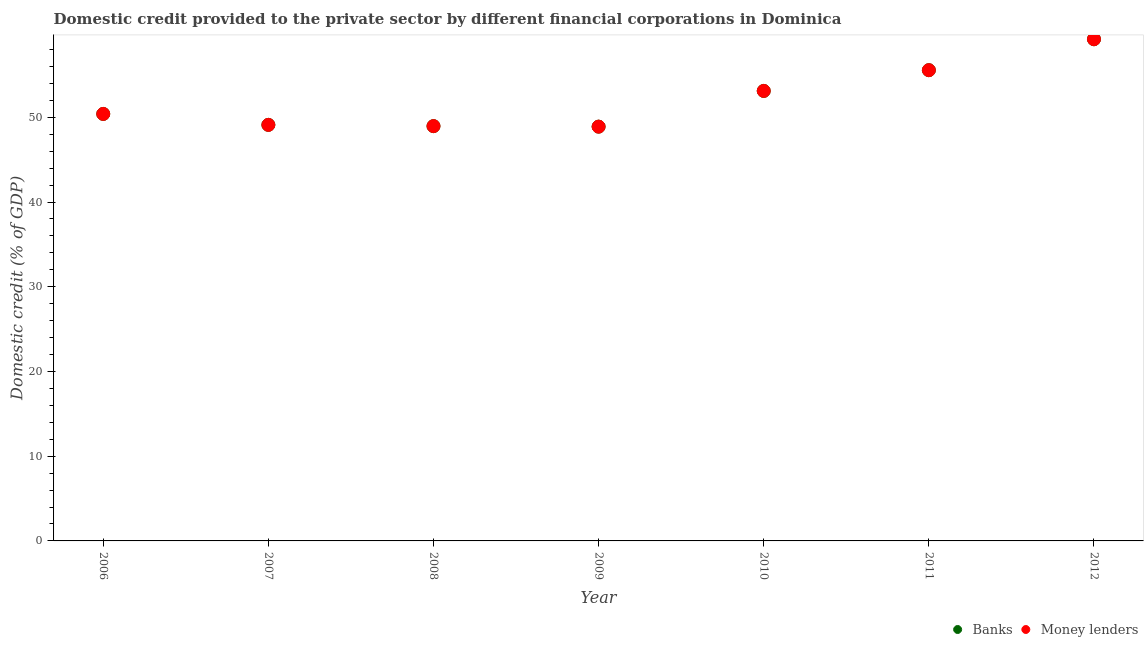How many different coloured dotlines are there?
Keep it short and to the point. 2. What is the domestic credit provided by money lenders in 2011?
Your answer should be compact. 55.56. Across all years, what is the maximum domestic credit provided by banks?
Your response must be concise. 59.21. Across all years, what is the minimum domestic credit provided by money lenders?
Offer a terse response. 48.9. In which year was the domestic credit provided by banks maximum?
Keep it short and to the point. 2012. What is the total domestic credit provided by banks in the graph?
Give a very brief answer. 365.26. What is the difference between the domestic credit provided by banks in 2006 and that in 2010?
Ensure brevity in your answer.  -2.72. What is the difference between the domestic credit provided by banks in 2010 and the domestic credit provided by money lenders in 2009?
Provide a succinct answer. 4.22. What is the average domestic credit provided by banks per year?
Offer a very short reply. 52.18. What is the ratio of the domestic credit provided by banks in 2006 to that in 2011?
Your answer should be very brief. 0.91. Is the difference between the domestic credit provided by money lenders in 2010 and 2012 greater than the difference between the domestic credit provided by banks in 2010 and 2012?
Provide a short and direct response. No. What is the difference between the highest and the second highest domestic credit provided by banks?
Your response must be concise. 3.65. What is the difference between the highest and the lowest domestic credit provided by banks?
Make the answer very short. 10.32. Is the sum of the domestic credit provided by money lenders in 2006 and 2009 greater than the maximum domestic credit provided by banks across all years?
Give a very brief answer. Yes. Is the domestic credit provided by money lenders strictly greater than the domestic credit provided by banks over the years?
Provide a short and direct response. No. Is the domestic credit provided by money lenders strictly less than the domestic credit provided by banks over the years?
Offer a terse response. No. What is the difference between two consecutive major ticks on the Y-axis?
Your response must be concise. 10. Does the graph contain any zero values?
Your answer should be compact. No. Does the graph contain grids?
Your answer should be very brief. No. Where does the legend appear in the graph?
Your response must be concise. Bottom right. How many legend labels are there?
Offer a very short reply. 2. What is the title of the graph?
Offer a very short reply. Domestic credit provided to the private sector by different financial corporations in Dominica. What is the label or title of the X-axis?
Offer a terse response. Year. What is the label or title of the Y-axis?
Your answer should be compact. Domestic credit (% of GDP). What is the Domestic credit (% of GDP) in Banks in 2006?
Provide a short and direct response. 50.4. What is the Domestic credit (% of GDP) in Money lenders in 2006?
Keep it short and to the point. 50.4. What is the Domestic credit (% of GDP) of Banks in 2007?
Give a very brief answer. 49.11. What is the Domestic credit (% of GDP) of Money lenders in 2007?
Provide a short and direct response. 49.11. What is the Domestic credit (% of GDP) of Banks in 2008?
Your answer should be very brief. 48.96. What is the Domestic credit (% of GDP) in Money lenders in 2008?
Your response must be concise. 48.96. What is the Domestic credit (% of GDP) of Banks in 2009?
Keep it short and to the point. 48.9. What is the Domestic credit (% of GDP) in Money lenders in 2009?
Give a very brief answer. 48.9. What is the Domestic credit (% of GDP) in Banks in 2010?
Keep it short and to the point. 53.12. What is the Domestic credit (% of GDP) in Money lenders in 2010?
Your answer should be very brief. 53.12. What is the Domestic credit (% of GDP) of Banks in 2011?
Give a very brief answer. 55.56. What is the Domestic credit (% of GDP) of Money lenders in 2011?
Your response must be concise. 55.56. What is the Domestic credit (% of GDP) of Banks in 2012?
Give a very brief answer. 59.21. What is the Domestic credit (% of GDP) in Money lenders in 2012?
Your answer should be very brief. 59.21. Across all years, what is the maximum Domestic credit (% of GDP) in Banks?
Offer a very short reply. 59.21. Across all years, what is the maximum Domestic credit (% of GDP) of Money lenders?
Your response must be concise. 59.21. Across all years, what is the minimum Domestic credit (% of GDP) of Banks?
Keep it short and to the point. 48.9. Across all years, what is the minimum Domestic credit (% of GDP) in Money lenders?
Provide a short and direct response. 48.9. What is the total Domestic credit (% of GDP) in Banks in the graph?
Make the answer very short. 365.26. What is the total Domestic credit (% of GDP) of Money lenders in the graph?
Provide a short and direct response. 365.26. What is the difference between the Domestic credit (% of GDP) in Banks in 2006 and that in 2007?
Provide a succinct answer. 1.29. What is the difference between the Domestic credit (% of GDP) in Money lenders in 2006 and that in 2007?
Offer a terse response. 1.29. What is the difference between the Domestic credit (% of GDP) of Banks in 2006 and that in 2008?
Give a very brief answer. 1.44. What is the difference between the Domestic credit (% of GDP) in Money lenders in 2006 and that in 2008?
Offer a terse response. 1.44. What is the difference between the Domestic credit (% of GDP) of Banks in 2006 and that in 2009?
Your answer should be very brief. 1.5. What is the difference between the Domestic credit (% of GDP) of Money lenders in 2006 and that in 2009?
Ensure brevity in your answer.  1.5. What is the difference between the Domestic credit (% of GDP) in Banks in 2006 and that in 2010?
Your response must be concise. -2.72. What is the difference between the Domestic credit (% of GDP) of Money lenders in 2006 and that in 2010?
Provide a succinct answer. -2.72. What is the difference between the Domestic credit (% of GDP) of Banks in 2006 and that in 2011?
Your answer should be very brief. -5.17. What is the difference between the Domestic credit (% of GDP) in Money lenders in 2006 and that in 2011?
Your response must be concise. -5.17. What is the difference between the Domestic credit (% of GDP) of Banks in 2006 and that in 2012?
Make the answer very short. -8.82. What is the difference between the Domestic credit (% of GDP) of Money lenders in 2006 and that in 2012?
Provide a short and direct response. -8.82. What is the difference between the Domestic credit (% of GDP) of Banks in 2007 and that in 2008?
Your answer should be compact. 0.15. What is the difference between the Domestic credit (% of GDP) in Money lenders in 2007 and that in 2008?
Your response must be concise. 0.15. What is the difference between the Domestic credit (% of GDP) in Banks in 2007 and that in 2009?
Your response must be concise. 0.21. What is the difference between the Domestic credit (% of GDP) in Money lenders in 2007 and that in 2009?
Ensure brevity in your answer.  0.21. What is the difference between the Domestic credit (% of GDP) of Banks in 2007 and that in 2010?
Keep it short and to the point. -4.01. What is the difference between the Domestic credit (% of GDP) in Money lenders in 2007 and that in 2010?
Offer a terse response. -4.01. What is the difference between the Domestic credit (% of GDP) of Banks in 2007 and that in 2011?
Make the answer very short. -6.46. What is the difference between the Domestic credit (% of GDP) of Money lenders in 2007 and that in 2011?
Your answer should be very brief. -6.46. What is the difference between the Domestic credit (% of GDP) in Banks in 2007 and that in 2012?
Give a very brief answer. -10.11. What is the difference between the Domestic credit (% of GDP) of Money lenders in 2007 and that in 2012?
Ensure brevity in your answer.  -10.11. What is the difference between the Domestic credit (% of GDP) of Banks in 2008 and that in 2009?
Provide a short and direct response. 0.06. What is the difference between the Domestic credit (% of GDP) in Money lenders in 2008 and that in 2009?
Ensure brevity in your answer.  0.06. What is the difference between the Domestic credit (% of GDP) of Banks in 2008 and that in 2010?
Provide a succinct answer. -4.15. What is the difference between the Domestic credit (% of GDP) in Money lenders in 2008 and that in 2010?
Provide a succinct answer. -4.15. What is the difference between the Domestic credit (% of GDP) of Banks in 2008 and that in 2011?
Offer a very short reply. -6.6. What is the difference between the Domestic credit (% of GDP) in Money lenders in 2008 and that in 2011?
Keep it short and to the point. -6.6. What is the difference between the Domestic credit (% of GDP) of Banks in 2008 and that in 2012?
Your answer should be very brief. -10.25. What is the difference between the Domestic credit (% of GDP) in Money lenders in 2008 and that in 2012?
Make the answer very short. -10.25. What is the difference between the Domestic credit (% of GDP) in Banks in 2009 and that in 2010?
Ensure brevity in your answer.  -4.22. What is the difference between the Domestic credit (% of GDP) in Money lenders in 2009 and that in 2010?
Provide a succinct answer. -4.22. What is the difference between the Domestic credit (% of GDP) in Banks in 2009 and that in 2011?
Offer a terse response. -6.67. What is the difference between the Domestic credit (% of GDP) of Money lenders in 2009 and that in 2011?
Provide a succinct answer. -6.67. What is the difference between the Domestic credit (% of GDP) of Banks in 2009 and that in 2012?
Provide a succinct answer. -10.32. What is the difference between the Domestic credit (% of GDP) of Money lenders in 2009 and that in 2012?
Your answer should be very brief. -10.32. What is the difference between the Domestic credit (% of GDP) of Banks in 2010 and that in 2011?
Give a very brief answer. -2.45. What is the difference between the Domestic credit (% of GDP) in Money lenders in 2010 and that in 2011?
Your answer should be very brief. -2.45. What is the difference between the Domestic credit (% of GDP) in Banks in 2010 and that in 2012?
Your answer should be very brief. -6.1. What is the difference between the Domestic credit (% of GDP) of Money lenders in 2010 and that in 2012?
Make the answer very short. -6.1. What is the difference between the Domestic credit (% of GDP) of Banks in 2011 and that in 2012?
Offer a terse response. -3.65. What is the difference between the Domestic credit (% of GDP) in Money lenders in 2011 and that in 2012?
Your response must be concise. -3.65. What is the difference between the Domestic credit (% of GDP) in Banks in 2006 and the Domestic credit (% of GDP) in Money lenders in 2007?
Provide a short and direct response. 1.29. What is the difference between the Domestic credit (% of GDP) in Banks in 2006 and the Domestic credit (% of GDP) in Money lenders in 2008?
Your answer should be very brief. 1.44. What is the difference between the Domestic credit (% of GDP) of Banks in 2006 and the Domestic credit (% of GDP) of Money lenders in 2009?
Offer a terse response. 1.5. What is the difference between the Domestic credit (% of GDP) in Banks in 2006 and the Domestic credit (% of GDP) in Money lenders in 2010?
Provide a short and direct response. -2.72. What is the difference between the Domestic credit (% of GDP) of Banks in 2006 and the Domestic credit (% of GDP) of Money lenders in 2011?
Provide a succinct answer. -5.17. What is the difference between the Domestic credit (% of GDP) in Banks in 2006 and the Domestic credit (% of GDP) in Money lenders in 2012?
Offer a very short reply. -8.82. What is the difference between the Domestic credit (% of GDP) of Banks in 2007 and the Domestic credit (% of GDP) of Money lenders in 2008?
Offer a terse response. 0.15. What is the difference between the Domestic credit (% of GDP) in Banks in 2007 and the Domestic credit (% of GDP) in Money lenders in 2009?
Your answer should be compact. 0.21. What is the difference between the Domestic credit (% of GDP) in Banks in 2007 and the Domestic credit (% of GDP) in Money lenders in 2010?
Ensure brevity in your answer.  -4.01. What is the difference between the Domestic credit (% of GDP) of Banks in 2007 and the Domestic credit (% of GDP) of Money lenders in 2011?
Give a very brief answer. -6.46. What is the difference between the Domestic credit (% of GDP) of Banks in 2007 and the Domestic credit (% of GDP) of Money lenders in 2012?
Provide a succinct answer. -10.11. What is the difference between the Domestic credit (% of GDP) of Banks in 2008 and the Domestic credit (% of GDP) of Money lenders in 2009?
Your answer should be compact. 0.06. What is the difference between the Domestic credit (% of GDP) in Banks in 2008 and the Domestic credit (% of GDP) in Money lenders in 2010?
Make the answer very short. -4.15. What is the difference between the Domestic credit (% of GDP) in Banks in 2008 and the Domestic credit (% of GDP) in Money lenders in 2011?
Offer a very short reply. -6.6. What is the difference between the Domestic credit (% of GDP) in Banks in 2008 and the Domestic credit (% of GDP) in Money lenders in 2012?
Offer a very short reply. -10.25. What is the difference between the Domestic credit (% of GDP) in Banks in 2009 and the Domestic credit (% of GDP) in Money lenders in 2010?
Make the answer very short. -4.22. What is the difference between the Domestic credit (% of GDP) of Banks in 2009 and the Domestic credit (% of GDP) of Money lenders in 2011?
Provide a short and direct response. -6.67. What is the difference between the Domestic credit (% of GDP) in Banks in 2009 and the Domestic credit (% of GDP) in Money lenders in 2012?
Offer a very short reply. -10.32. What is the difference between the Domestic credit (% of GDP) in Banks in 2010 and the Domestic credit (% of GDP) in Money lenders in 2011?
Offer a terse response. -2.45. What is the difference between the Domestic credit (% of GDP) of Banks in 2010 and the Domestic credit (% of GDP) of Money lenders in 2012?
Provide a succinct answer. -6.1. What is the difference between the Domestic credit (% of GDP) in Banks in 2011 and the Domestic credit (% of GDP) in Money lenders in 2012?
Make the answer very short. -3.65. What is the average Domestic credit (% of GDP) in Banks per year?
Provide a succinct answer. 52.18. What is the average Domestic credit (% of GDP) of Money lenders per year?
Provide a short and direct response. 52.18. In the year 2007, what is the difference between the Domestic credit (% of GDP) in Banks and Domestic credit (% of GDP) in Money lenders?
Your response must be concise. 0. In the year 2008, what is the difference between the Domestic credit (% of GDP) in Banks and Domestic credit (% of GDP) in Money lenders?
Your answer should be very brief. 0. In the year 2009, what is the difference between the Domestic credit (% of GDP) in Banks and Domestic credit (% of GDP) in Money lenders?
Your answer should be very brief. 0. In the year 2010, what is the difference between the Domestic credit (% of GDP) of Banks and Domestic credit (% of GDP) of Money lenders?
Give a very brief answer. 0. In the year 2012, what is the difference between the Domestic credit (% of GDP) of Banks and Domestic credit (% of GDP) of Money lenders?
Your answer should be very brief. 0. What is the ratio of the Domestic credit (% of GDP) in Banks in 2006 to that in 2007?
Your answer should be very brief. 1.03. What is the ratio of the Domestic credit (% of GDP) of Money lenders in 2006 to that in 2007?
Keep it short and to the point. 1.03. What is the ratio of the Domestic credit (% of GDP) in Banks in 2006 to that in 2008?
Your answer should be very brief. 1.03. What is the ratio of the Domestic credit (% of GDP) of Money lenders in 2006 to that in 2008?
Give a very brief answer. 1.03. What is the ratio of the Domestic credit (% of GDP) in Banks in 2006 to that in 2009?
Your response must be concise. 1.03. What is the ratio of the Domestic credit (% of GDP) of Money lenders in 2006 to that in 2009?
Your response must be concise. 1.03. What is the ratio of the Domestic credit (% of GDP) in Banks in 2006 to that in 2010?
Your answer should be very brief. 0.95. What is the ratio of the Domestic credit (% of GDP) of Money lenders in 2006 to that in 2010?
Your response must be concise. 0.95. What is the ratio of the Domestic credit (% of GDP) of Banks in 2006 to that in 2011?
Give a very brief answer. 0.91. What is the ratio of the Domestic credit (% of GDP) of Money lenders in 2006 to that in 2011?
Your response must be concise. 0.91. What is the ratio of the Domestic credit (% of GDP) in Banks in 2006 to that in 2012?
Provide a short and direct response. 0.85. What is the ratio of the Domestic credit (% of GDP) of Money lenders in 2006 to that in 2012?
Offer a very short reply. 0.85. What is the ratio of the Domestic credit (% of GDP) of Banks in 2007 to that in 2008?
Offer a very short reply. 1. What is the ratio of the Domestic credit (% of GDP) in Money lenders in 2007 to that in 2008?
Offer a terse response. 1. What is the ratio of the Domestic credit (% of GDP) in Banks in 2007 to that in 2010?
Provide a succinct answer. 0.92. What is the ratio of the Domestic credit (% of GDP) of Money lenders in 2007 to that in 2010?
Keep it short and to the point. 0.92. What is the ratio of the Domestic credit (% of GDP) of Banks in 2007 to that in 2011?
Ensure brevity in your answer.  0.88. What is the ratio of the Domestic credit (% of GDP) of Money lenders in 2007 to that in 2011?
Your response must be concise. 0.88. What is the ratio of the Domestic credit (% of GDP) of Banks in 2007 to that in 2012?
Provide a short and direct response. 0.83. What is the ratio of the Domestic credit (% of GDP) of Money lenders in 2007 to that in 2012?
Provide a succinct answer. 0.83. What is the ratio of the Domestic credit (% of GDP) in Banks in 2008 to that in 2009?
Provide a short and direct response. 1. What is the ratio of the Domestic credit (% of GDP) of Banks in 2008 to that in 2010?
Give a very brief answer. 0.92. What is the ratio of the Domestic credit (% of GDP) of Money lenders in 2008 to that in 2010?
Provide a short and direct response. 0.92. What is the ratio of the Domestic credit (% of GDP) in Banks in 2008 to that in 2011?
Offer a very short reply. 0.88. What is the ratio of the Domestic credit (% of GDP) in Money lenders in 2008 to that in 2011?
Your answer should be very brief. 0.88. What is the ratio of the Domestic credit (% of GDP) in Banks in 2008 to that in 2012?
Your response must be concise. 0.83. What is the ratio of the Domestic credit (% of GDP) in Money lenders in 2008 to that in 2012?
Give a very brief answer. 0.83. What is the ratio of the Domestic credit (% of GDP) in Banks in 2009 to that in 2010?
Ensure brevity in your answer.  0.92. What is the ratio of the Domestic credit (% of GDP) of Money lenders in 2009 to that in 2010?
Keep it short and to the point. 0.92. What is the ratio of the Domestic credit (% of GDP) in Banks in 2009 to that in 2012?
Make the answer very short. 0.83. What is the ratio of the Domestic credit (% of GDP) in Money lenders in 2009 to that in 2012?
Offer a very short reply. 0.83. What is the ratio of the Domestic credit (% of GDP) of Banks in 2010 to that in 2011?
Provide a short and direct response. 0.96. What is the ratio of the Domestic credit (% of GDP) in Money lenders in 2010 to that in 2011?
Offer a terse response. 0.96. What is the ratio of the Domestic credit (% of GDP) in Banks in 2010 to that in 2012?
Offer a terse response. 0.9. What is the ratio of the Domestic credit (% of GDP) in Money lenders in 2010 to that in 2012?
Ensure brevity in your answer.  0.9. What is the ratio of the Domestic credit (% of GDP) in Banks in 2011 to that in 2012?
Give a very brief answer. 0.94. What is the ratio of the Domestic credit (% of GDP) in Money lenders in 2011 to that in 2012?
Offer a terse response. 0.94. What is the difference between the highest and the second highest Domestic credit (% of GDP) in Banks?
Provide a short and direct response. 3.65. What is the difference between the highest and the second highest Domestic credit (% of GDP) of Money lenders?
Offer a terse response. 3.65. What is the difference between the highest and the lowest Domestic credit (% of GDP) in Banks?
Your answer should be very brief. 10.32. What is the difference between the highest and the lowest Domestic credit (% of GDP) of Money lenders?
Make the answer very short. 10.32. 